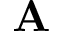Convert formula to latex. <formula><loc_0><loc_0><loc_500><loc_500>A</formula> 